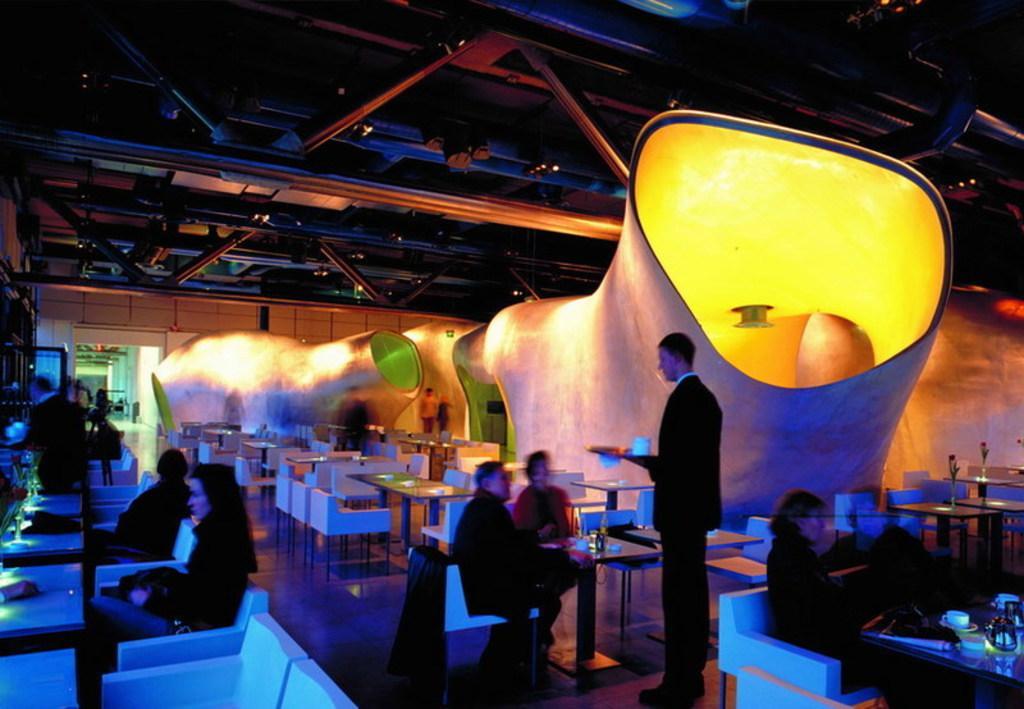In one or two sentences, can you explain what this image depicts? In this picture it looks like a restaurant with many tables and people on some of the chairs. We have glasses, plates, tablecloth on the table. On the rooftop we can see iron beams and bars & at the right side, we can see different shaped tunnels with lights. 